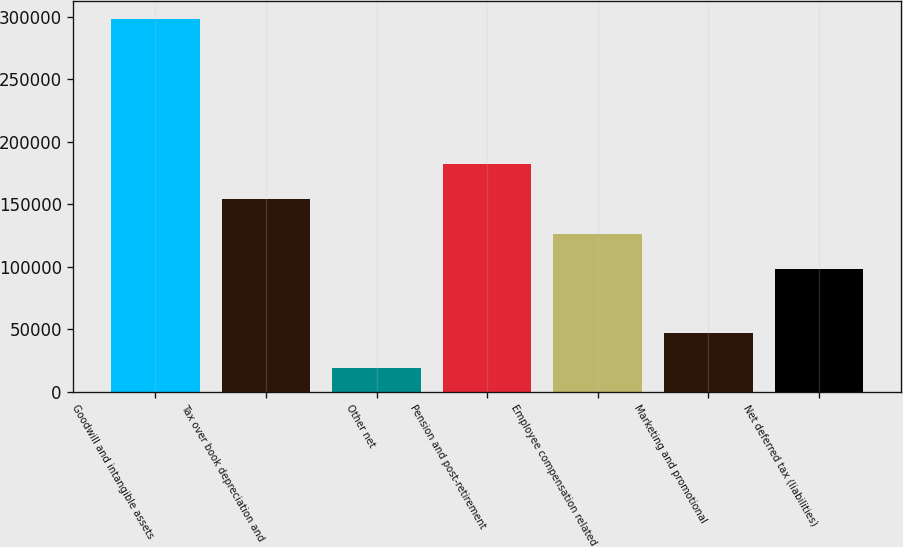Convert chart. <chart><loc_0><loc_0><loc_500><loc_500><bar_chart><fcel>Goodwill and intangible assets<fcel>Tax over book depreciation and<fcel>Other net<fcel>Pension and post-retirement<fcel>Employee compensation related<fcel>Marketing and promotional<fcel>Net deferred tax (liabilities)<nl><fcel>298159<fcel>154310<fcel>18657<fcel>182261<fcel>126360<fcel>46607.2<fcel>98410<nl></chart> 